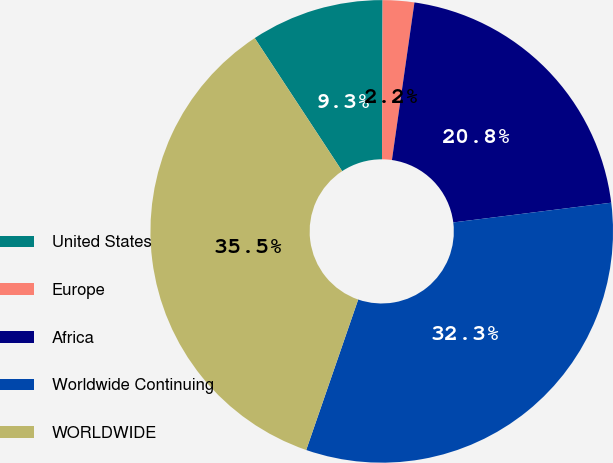Convert chart to OTSL. <chart><loc_0><loc_0><loc_500><loc_500><pie_chart><fcel>United States<fcel>Europe<fcel>Africa<fcel>Worldwide Continuing<fcel>WORLDWIDE<nl><fcel>9.31%<fcel>2.2%<fcel>20.76%<fcel>32.27%<fcel>35.45%<nl></chart> 